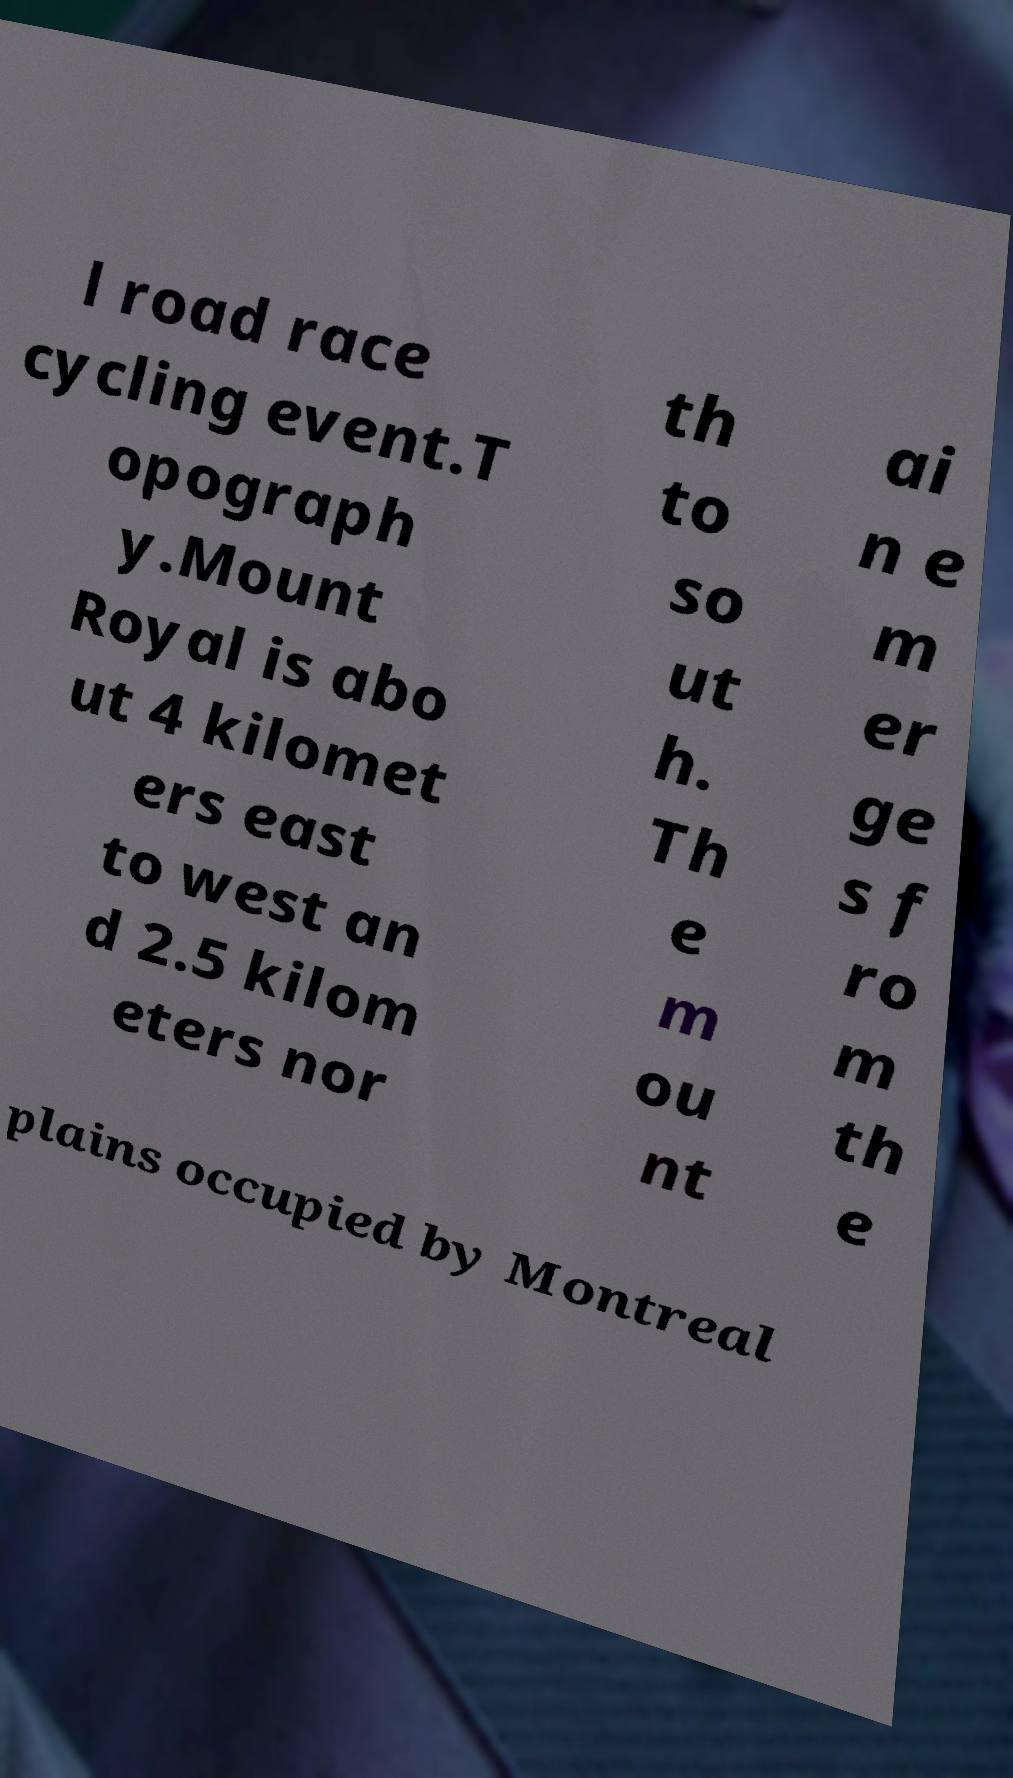Please identify and transcribe the text found in this image. l road race cycling event.T opograph y.Mount Royal is abo ut 4 kilomet ers east to west an d 2.5 kilom eters nor th to so ut h. Th e m ou nt ai n e m er ge s f ro m th e plains occupied by Montreal 